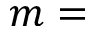<formula> <loc_0><loc_0><loc_500><loc_500>m =</formula> 